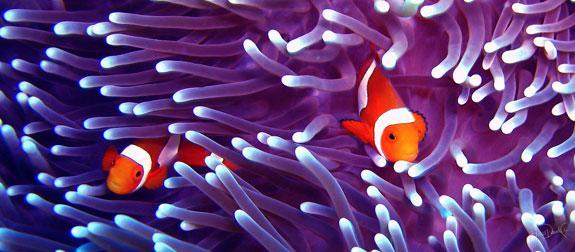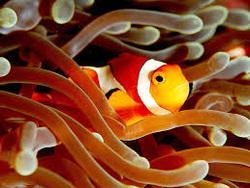The first image is the image on the left, the second image is the image on the right. For the images shown, is this caption "Exactly two clown-fish are interacting with an anemone in the left photo while exactly one fish is within the orange colored anemone in the right photo." true? Answer yes or no. Yes. The first image is the image on the left, the second image is the image on the right. Given the left and right images, does the statement "The left image features exactly two clown fish swimming in anemone tendrils, and the right image features one fish swimming in a different color of anemone tendrils." hold true? Answer yes or no. Yes. 